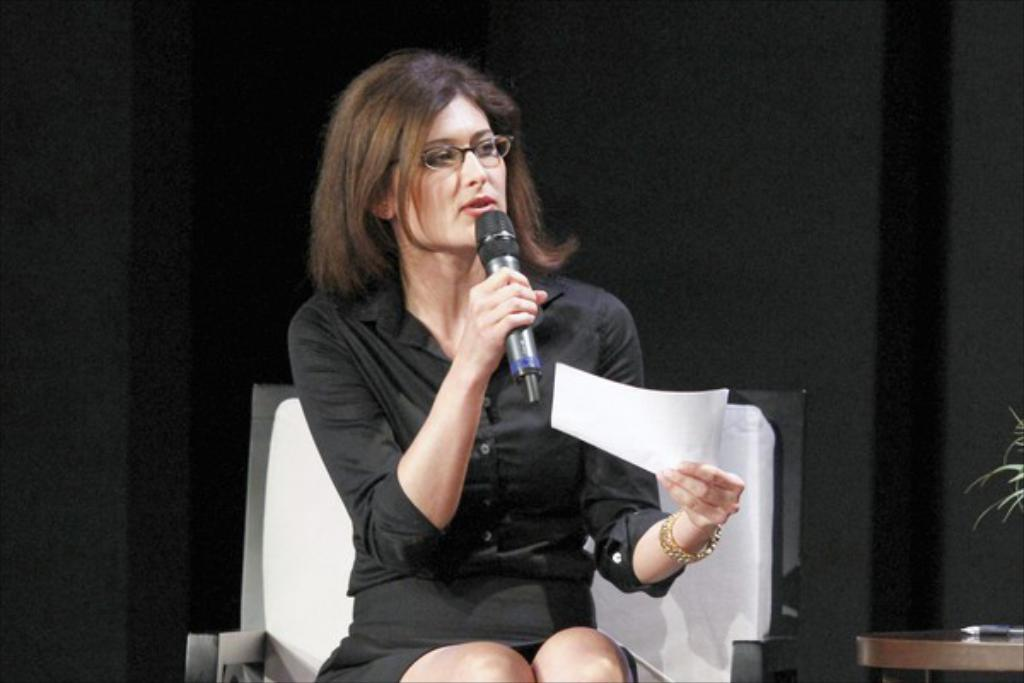Who is the main subject in the image? There is a woman in the image. What is the woman wearing? The woman is wearing a black dress. What is the woman doing in the image? The woman is talking on a mic and holding a paper. What is the woman's position in the image? The woman is sitting on a chair. What can be seen behind the woman in the image? There is a black wall behind the woman. What type of camera is the woman using to take pictures in the image? There is no camera present in the image, and the woman is not taking pictures. 